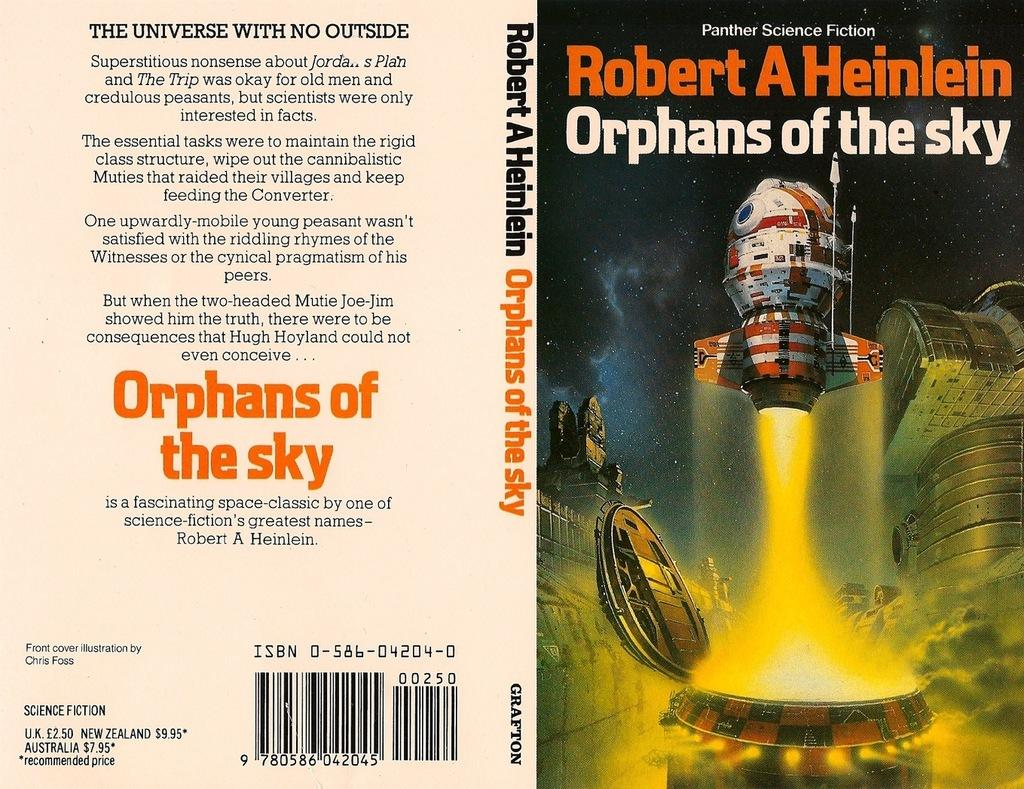What is present on the left side of the poster in the image? The poster has text on the left side. What can be found on the right side of the poster in the image? The poster has text and an image on the right side. How many snakes are crawling on the poster in the image? There are no snakes present on the poster in the image. What type of range is depicted on the poster in the image? There is no range depicted on the poster in the image. 